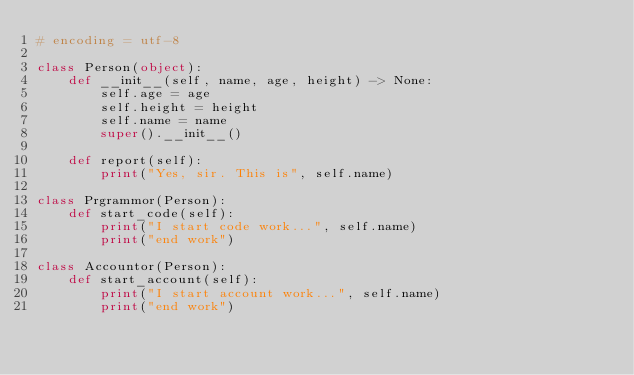<code> <loc_0><loc_0><loc_500><loc_500><_Python_># encoding = utf-8

class Person(object):
    def __init__(self, name, age, height) -> None:
        self.age = age
        self.height = height
        self.name = name
        super().__init__()
    
    def report(self):
        print("Yes, sir. This is", self.name)

class Prgrammor(Person):
    def start_code(self):
        print("I start code work...", self.name)
        print("end work")

class Accountor(Person):
    def start_account(self):
        print("I start account work...", self.name)
        print("end work")
</code> 